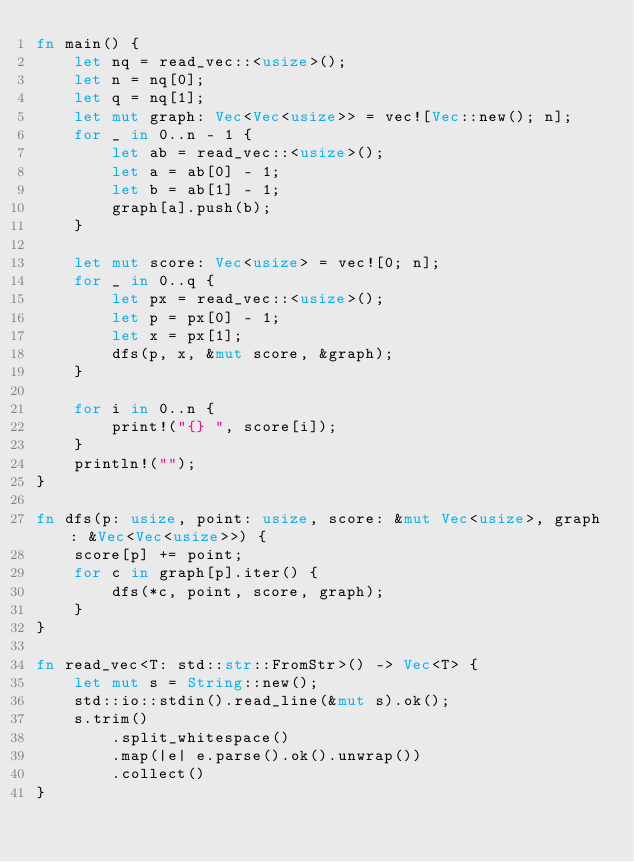Convert code to text. <code><loc_0><loc_0><loc_500><loc_500><_Rust_>fn main() {
    let nq = read_vec::<usize>();
    let n = nq[0];
    let q = nq[1];
    let mut graph: Vec<Vec<usize>> = vec![Vec::new(); n];
    for _ in 0..n - 1 {
        let ab = read_vec::<usize>();
        let a = ab[0] - 1;
        let b = ab[1] - 1;
        graph[a].push(b);
    }

    let mut score: Vec<usize> = vec![0; n];
    for _ in 0..q {
        let px = read_vec::<usize>();
        let p = px[0] - 1;
        let x = px[1];
        dfs(p, x, &mut score, &graph);
    }

    for i in 0..n {
        print!("{} ", score[i]);
    }
    println!("");
}

fn dfs(p: usize, point: usize, score: &mut Vec<usize>, graph: &Vec<Vec<usize>>) {
    score[p] += point;
    for c in graph[p].iter() {
        dfs(*c, point, score, graph);
    }
}

fn read_vec<T: std::str::FromStr>() -> Vec<T> {
    let mut s = String::new();
    std::io::stdin().read_line(&mut s).ok();
    s.trim()
        .split_whitespace()
        .map(|e| e.parse().ok().unwrap())
        .collect()
}
</code> 